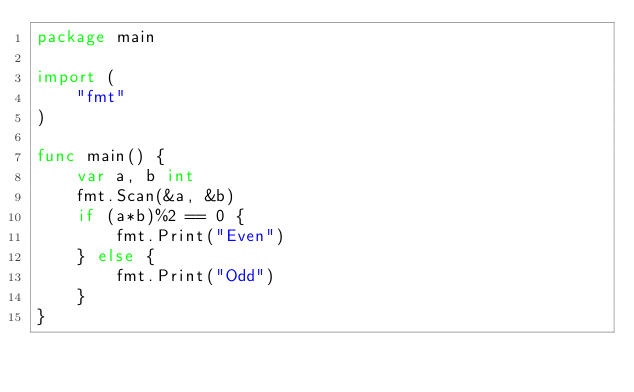Convert code to text. <code><loc_0><loc_0><loc_500><loc_500><_Go_>package main

import (
	"fmt"
)

func main() {
	var a, b int
	fmt.Scan(&a, &b)
	if (a*b)%2 == 0 {
		fmt.Print("Even")
	} else {
		fmt.Print("Odd")
	}
}
</code> 